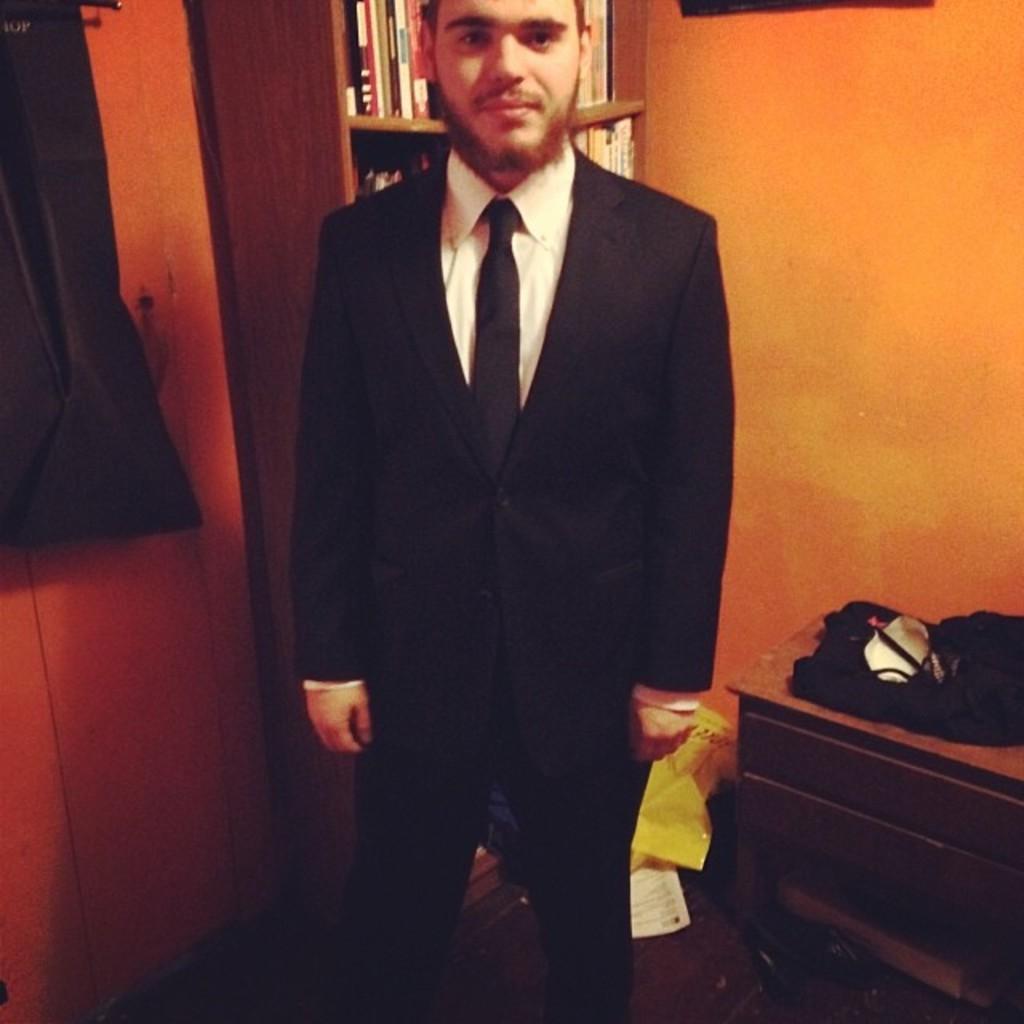Describe this image in one or two sentences. In this picture I can see a man standing, there are books in a bookshelf and there are some other objects, and in the background there is a wall. 